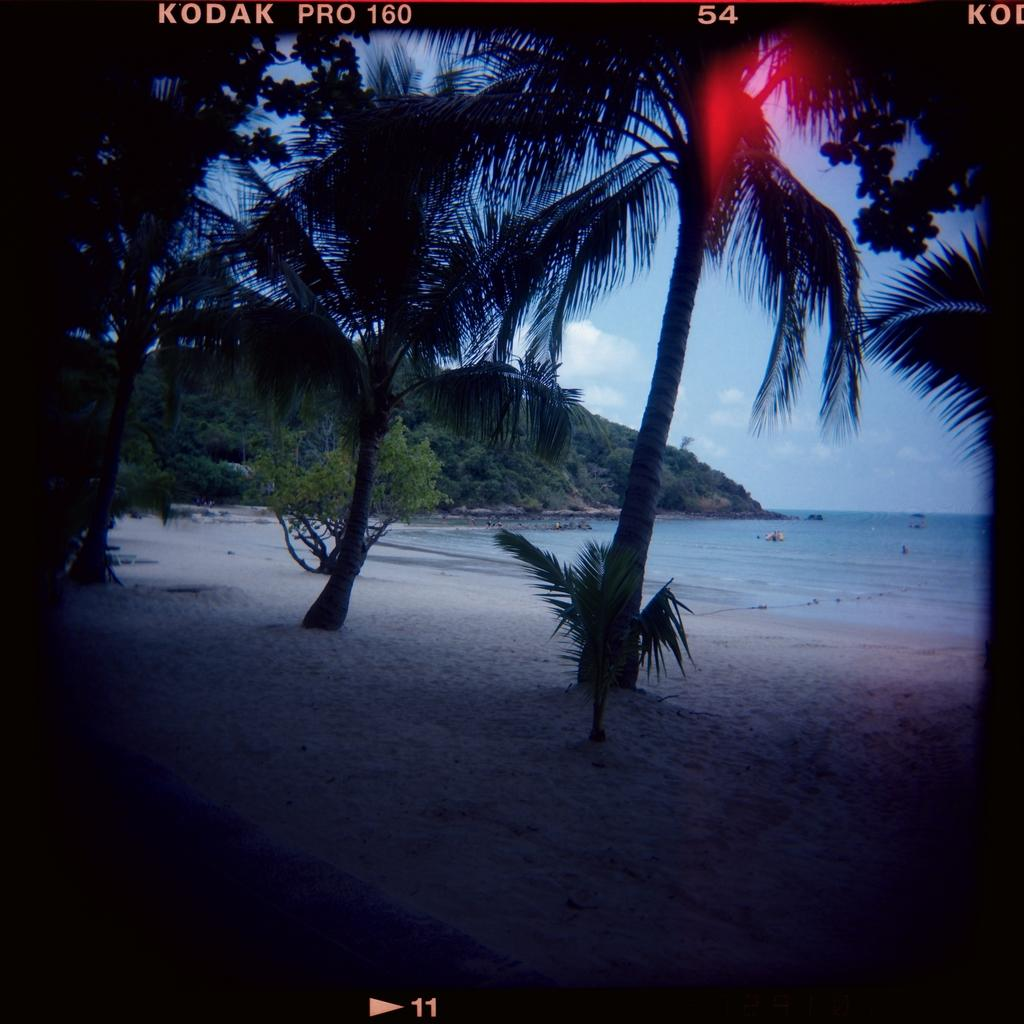What type of trees can be seen in the image? There are coconut trees in the image. Where are the coconut trees located? The coconut trees are near a beach. What can be seen on the right side of the image? There is water visible on the right side of the image. Can you see a shoe hanging from one of the coconut trees in the image? No, there is no shoe hanging from any of the coconut trees in the image. 